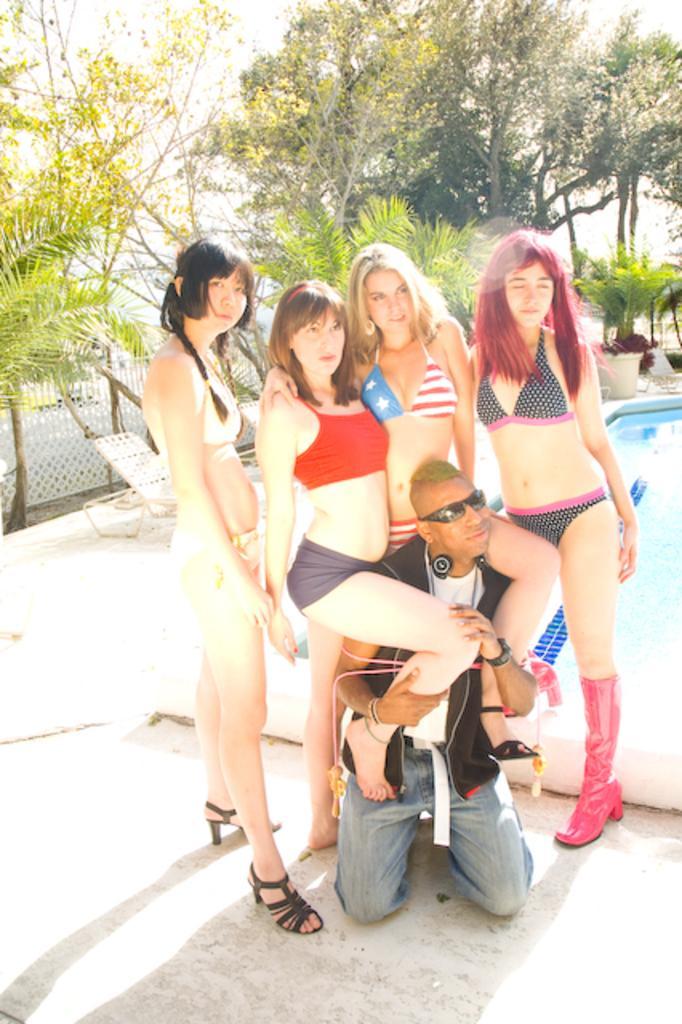In one or two sentences, can you explain what this image depicts? In this picture this 5 persons are highlighted and there are giving some stills. Far there are number of trees in green color. Beside this people there is a swimming pool with fresh water. Sky is in white color. Backside of this woman's there are chairs. Fence is in white color. 